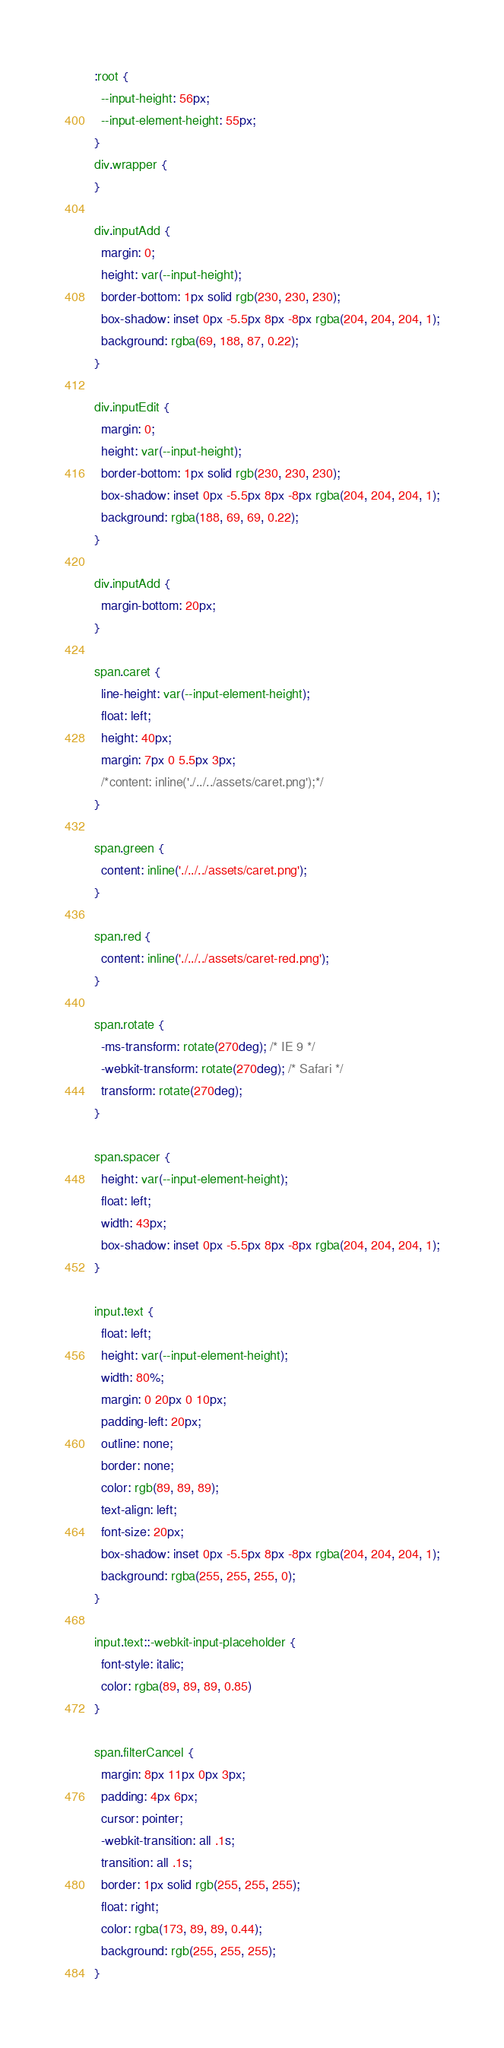Convert code to text. <code><loc_0><loc_0><loc_500><loc_500><_CSS_>:root {
  --input-height: 56px;
  --input-element-height: 55px;
}
div.wrapper {
}

div.inputAdd {
  margin: 0;
  height: var(--input-height);
  border-bottom: 1px solid rgb(230, 230, 230);
  box-shadow: inset 0px -5.5px 8px -8px rgba(204, 204, 204, 1);
  background: rgba(69, 188, 87, 0.22);
}

div.inputEdit {
  margin: 0;
  height: var(--input-height);
  border-bottom: 1px solid rgb(230, 230, 230);
  box-shadow: inset 0px -5.5px 8px -8px rgba(204, 204, 204, 1);
  background: rgba(188, 69, 69, 0.22);
}

div.inputAdd {
  margin-bottom: 20px;
}

span.caret {
  line-height: var(--input-element-height);
  float: left;
  height: 40px;
  margin: 7px 0 5.5px 3px;
  /*content: inline('./../../assets/caret.png');*/
}

span.green {
  content: inline('./../../assets/caret.png');
}

span.red {
  content: inline('./../../assets/caret-red.png');
}

span.rotate {
  -ms-transform: rotate(270deg); /* IE 9 */
  -webkit-transform: rotate(270deg); /* Safari */
  transform: rotate(270deg);
}

span.spacer {
  height: var(--input-element-height);
  float: left;
  width: 43px;
  box-shadow: inset 0px -5.5px 8px -8px rgba(204, 204, 204, 1);
}

input.text {
  float: left;
  height: var(--input-element-height);
  width: 80%;
  margin: 0 20px 0 10px;
  padding-left: 20px;
  outline: none;
  border: none;
  color: rgb(89, 89, 89);
  text-align: left;
  font-size: 20px;
  box-shadow: inset 0px -5.5px 8px -8px rgba(204, 204, 204, 1);
  background: rgba(255, 255, 255, 0);
}

input.text::-webkit-input-placeholder {
  font-style: italic;
  color: rgba(89, 89, 89, 0.85)
}

span.filterCancel {
  margin: 8px 11px 0px 3px;
  padding: 4px 6px;
  cursor: pointer;
  -webkit-transition: all .1s;
  transition: all .1s;
  border: 1px solid rgb(255, 255, 255);
  float: right;
  color: rgba(173, 89, 89, 0.44);
  background: rgb(255, 255, 255);
}
</code> 